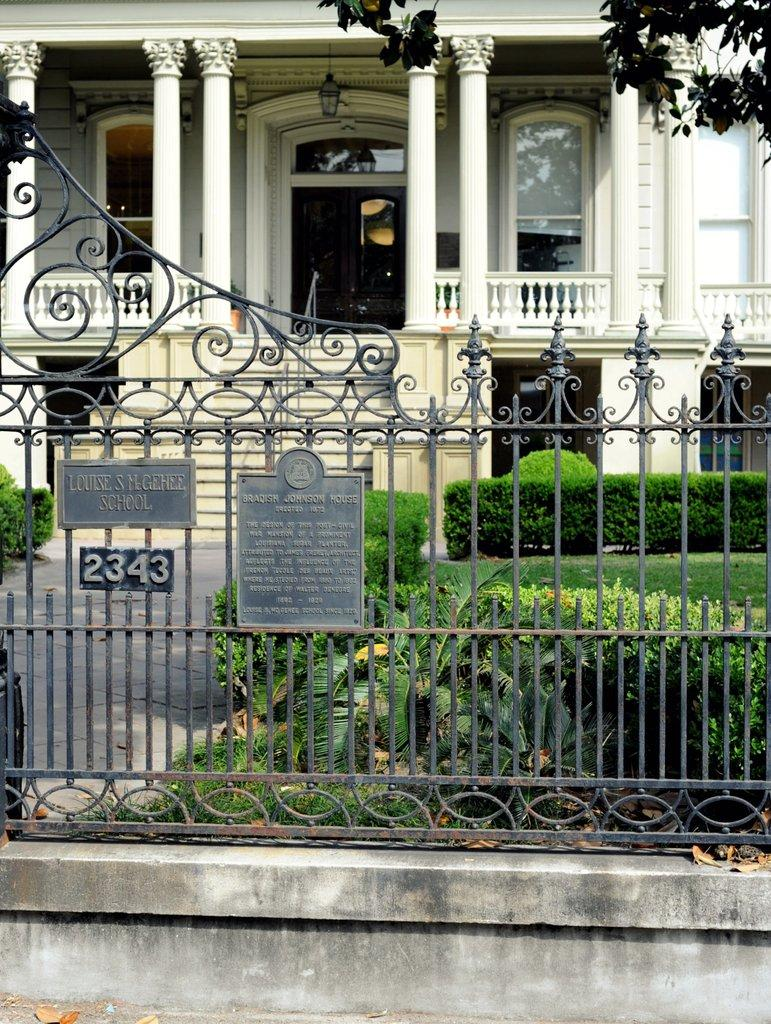What type of structure is visible in the image? There is a fencing in the image. What can be seen growing in the image? There are green color plants in the image. What type of man-made structure is present in the image? There is a building in the image. What type of guitar can be seen hanging on the wall in the image? There is no guitar present in the image; it features a fencing, green plants, and a building. What appliance is being used to water the plants in the image? There is no appliance visible in the image, as it only shows a fencing, green plants, and a building. 